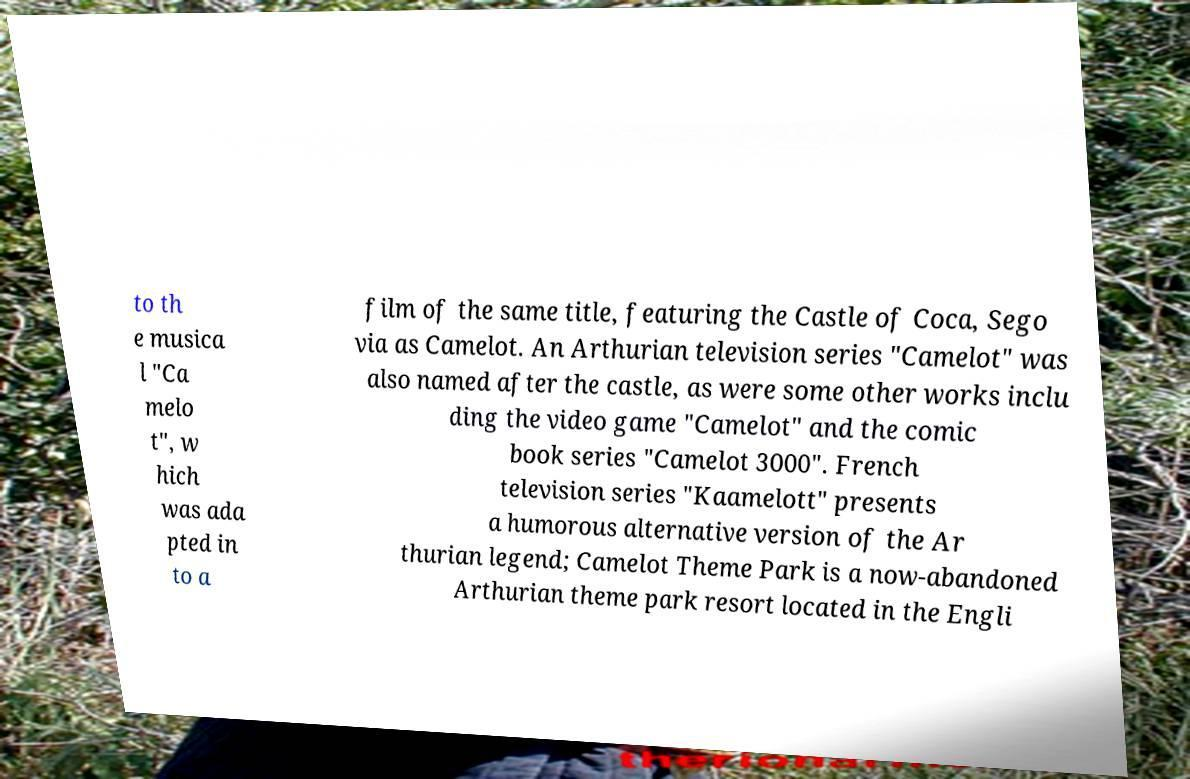Could you extract and type out the text from this image? to th e musica l "Ca melo t", w hich was ada pted in to a film of the same title, featuring the Castle of Coca, Sego via as Camelot. An Arthurian television series "Camelot" was also named after the castle, as were some other works inclu ding the video game "Camelot" and the comic book series "Camelot 3000". French television series "Kaamelott" presents a humorous alternative version of the Ar thurian legend; Camelot Theme Park is a now-abandoned Arthurian theme park resort located in the Engli 